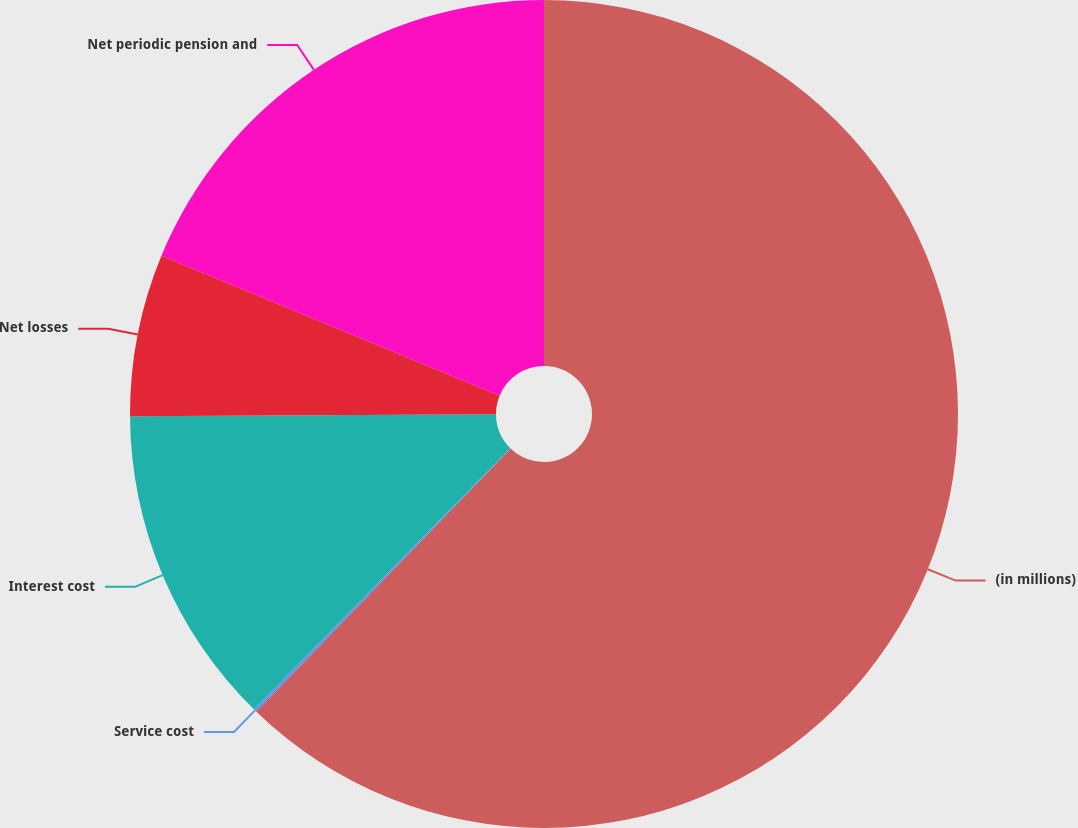Convert chart. <chart><loc_0><loc_0><loc_500><loc_500><pie_chart><fcel>(in millions)<fcel>Service cost<fcel>Interest cost<fcel>Net losses<fcel>Net periodic pension and<nl><fcel>62.24%<fcel>0.12%<fcel>12.55%<fcel>6.33%<fcel>18.76%<nl></chart> 